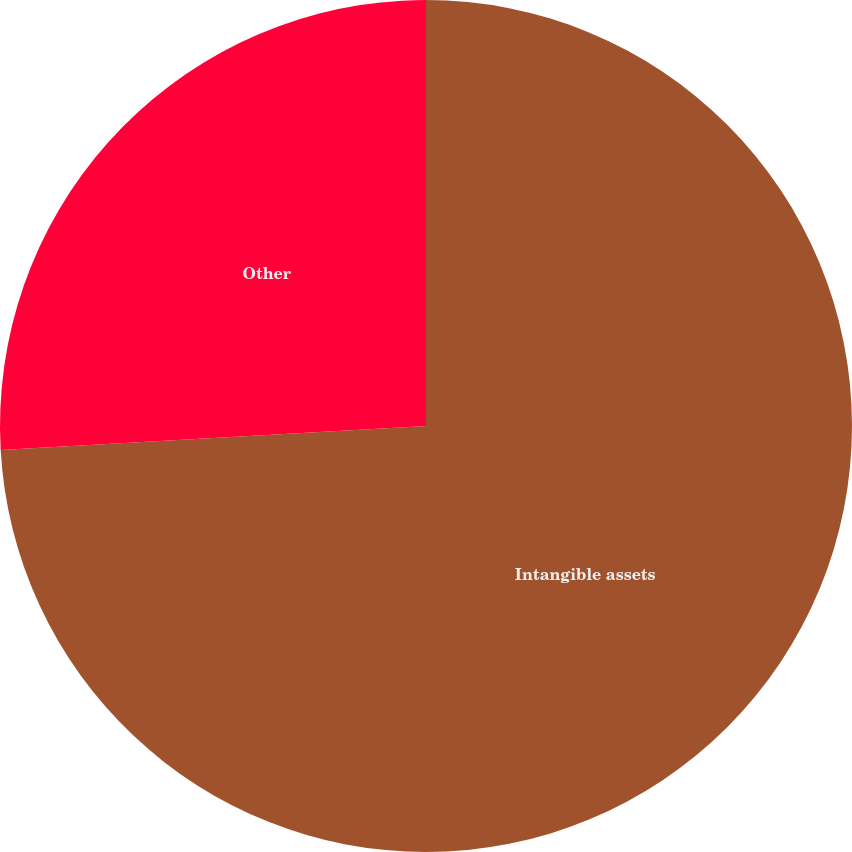Convert chart to OTSL. <chart><loc_0><loc_0><loc_500><loc_500><pie_chart><fcel>Intangible assets<fcel>Other<nl><fcel>74.1%<fcel>25.9%<nl></chart> 